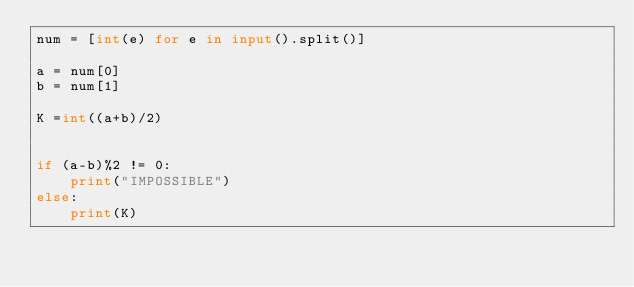Convert code to text. <code><loc_0><loc_0><loc_500><loc_500><_Python_>num = [int(e) for e in input().split()]

a = num[0]
b = num[1]

K =int((a+b)/2)


if (a-b)%2 != 0:
    print("IMPOSSIBLE")
else:
    print(K)</code> 